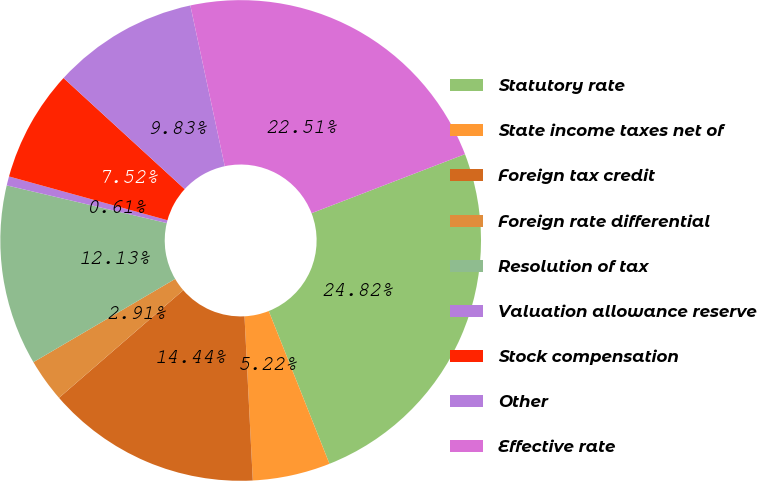Convert chart to OTSL. <chart><loc_0><loc_0><loc_500><loc_500><pie_chart><fcel>Statutory rate<fcel>State income taxes net of<fcel>Foreign tax credit<fcel>Foreign rate differential<fcel>Resolution of tax<fcel>Valuation allowance reserve<fcel>Stock compensation<fcel>Other<fcel>Effective rate<nl><fcel>24.82%<fcel>5.22%<fcel>14.44%<fcel>2.91%<fcel>12.13%<fcel>0.61%<fcel>7.52%<fcel>9.83%<fcel>22.51%<nl></chart> 